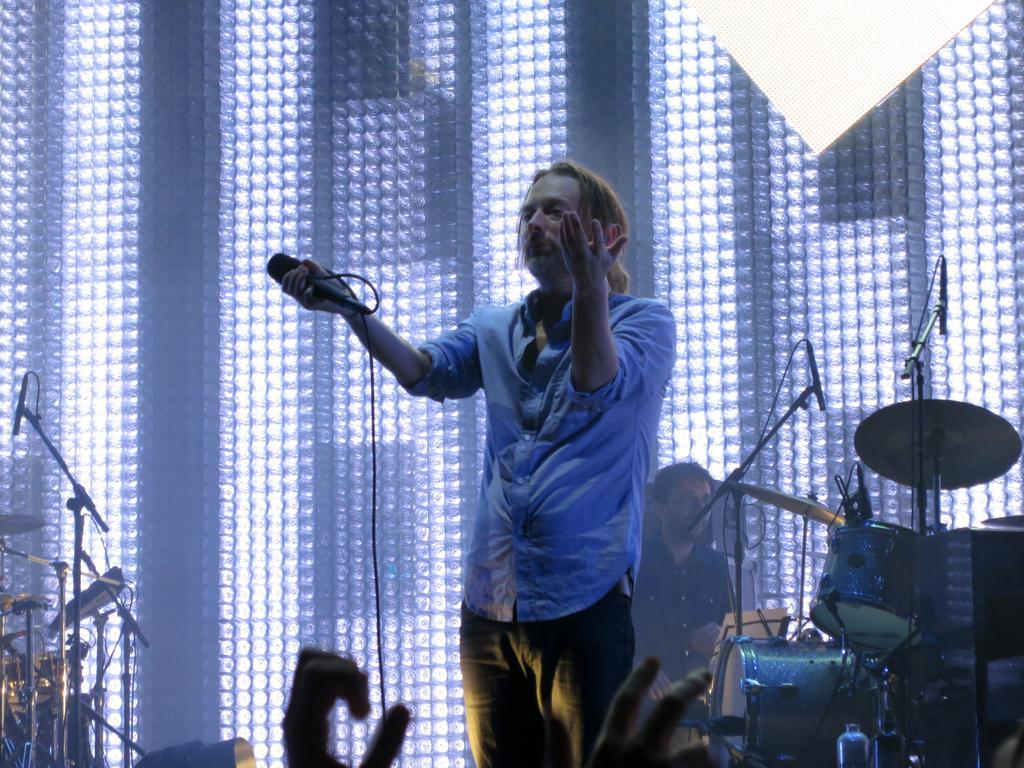How would you summarize this image in a sentence or two? In this image there is a person holding a mic, behind him there is a person sitting and there are some musical instruments. In front of the image there is a person's hand. In the background of the image there is a glass wall with lights. 